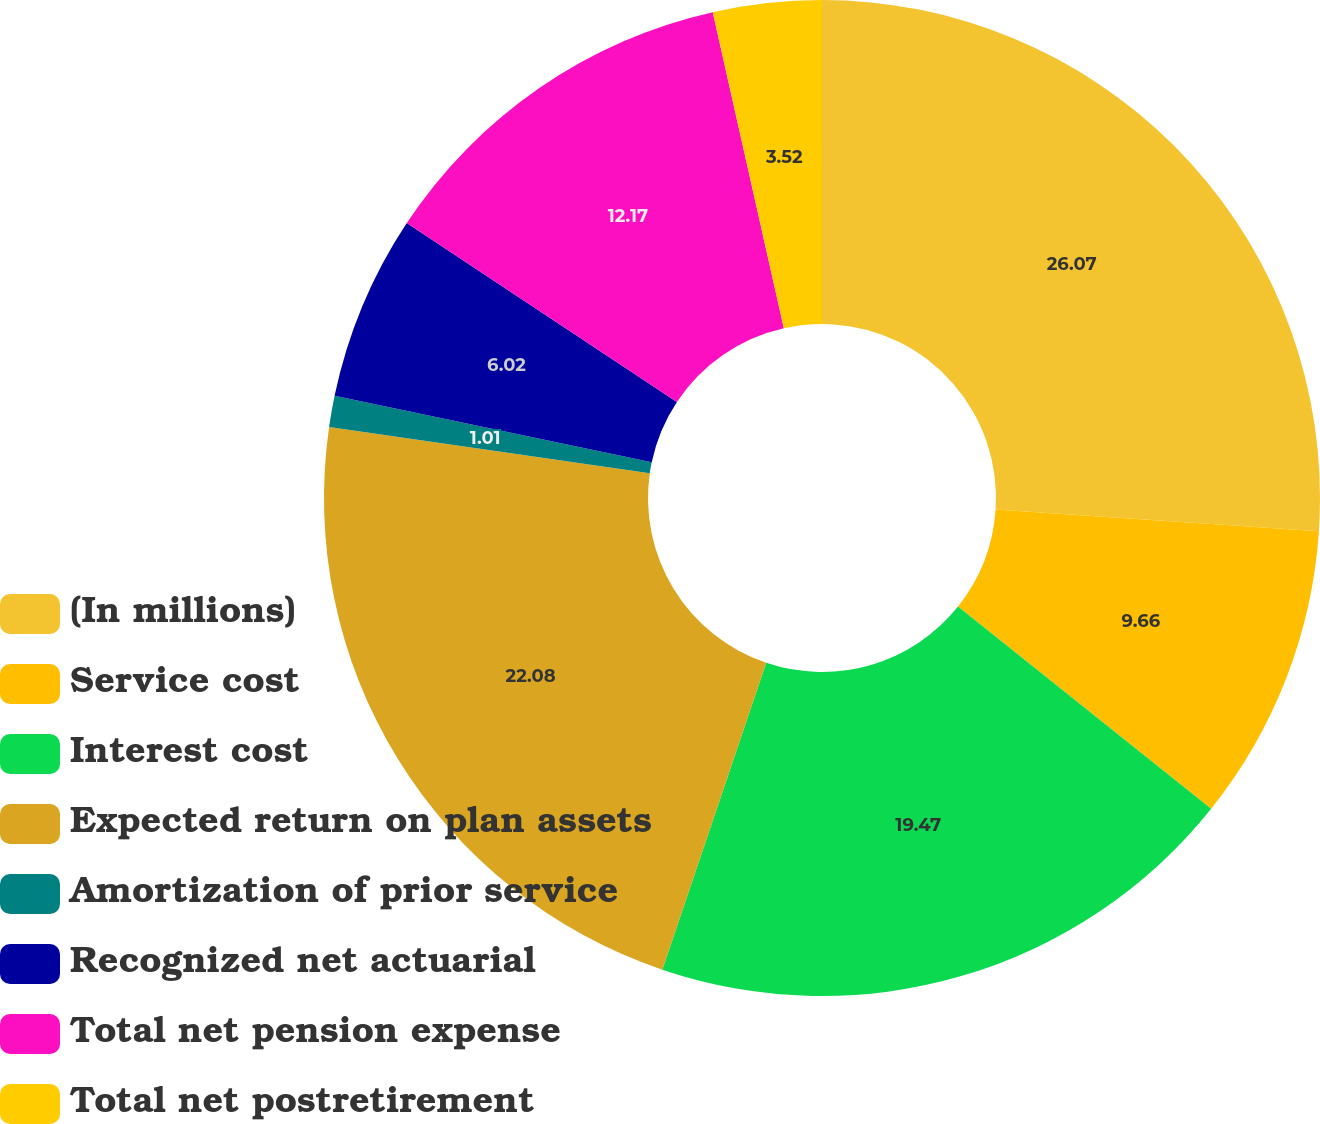<chart> <loc_0><loc_0><loc_500><loc_500><pie_chart><fcel>(In millions)<fcel>Service cost<fcel>Interest cost<fcel>Expected return on plan assets<fcel>Amortization of prior service<fcel>Recognized net actuarial<fcel>Total net pension expense<fcel>Total net postretirement<nl><fcel>26.06%<fcel>9.66%<fcel>19.47%<fcel>22.08%<fcel>1.01%<fcel>6.02%<fcel>12.17%<fcel>3.52%<nl></chart> 